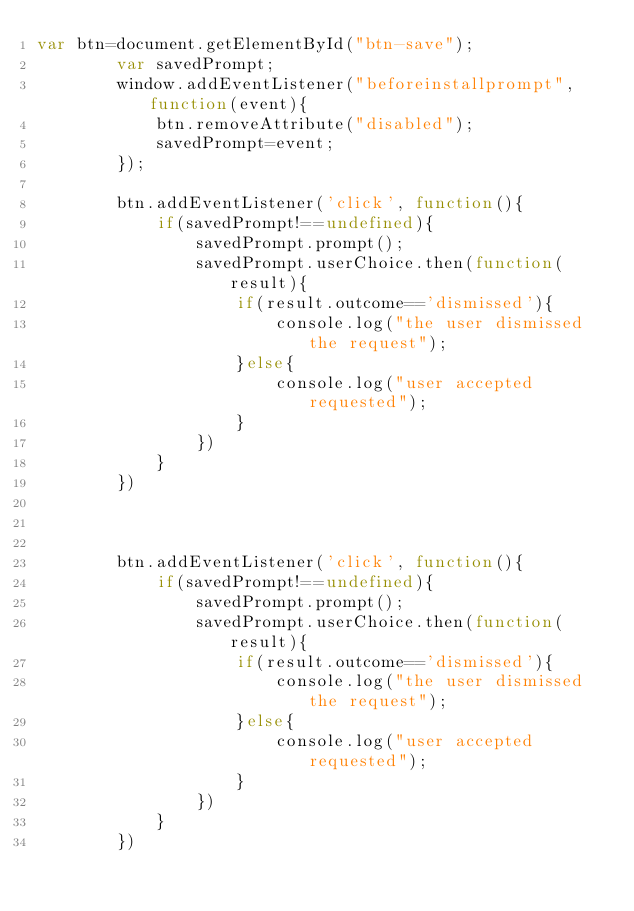<code> <loc_0><loc_0><loc_500><loc_500><_JavaScript_>var btn=document.getElementById("btn-save");
        var savedPrompt;
        window.addEventListener("beforeinstallprompt", function(event){
            btn.removeAttribute("disabled");
            savedPrompt=event;
        });
        
        btn.addEventListener('click', function(){
            if(savedPrompt!==undefined){
                savedPrompt.prompt();
                savedPrompt.userChoice.then(function(result){
                    if(result.outcome=='dismissed'){
                        console.log("the user dismissed the request");
                    }else{
                        console.log("user accepted requested");
                    }
                })
            }
        })
    
    
        
        btn.addEventListener('click', function(){
            if(savedPrompt!==undefined){
                savedPrompt.prompt();
                savedPrompt.userChoice.then(function(result){
                    if(result.outcome=='dismissed'){
                        console.log("the user dismissed the request");
                    }else{
                        console.log("user accepted requested");
                    }
                })
            }
        })</code> 